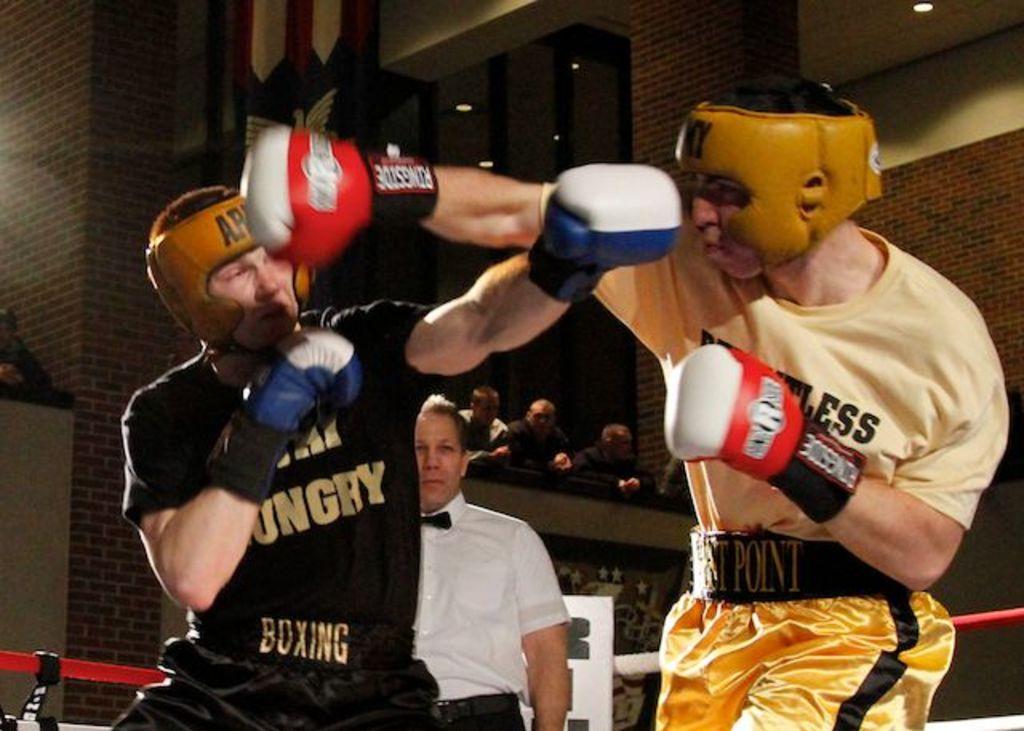In one or two sentences, can you explain what this image depicts? In this image we can see two persons boxing. In the background we can see a person with a white shirt. Image also consists of lights. There are also persons watching boxing. 